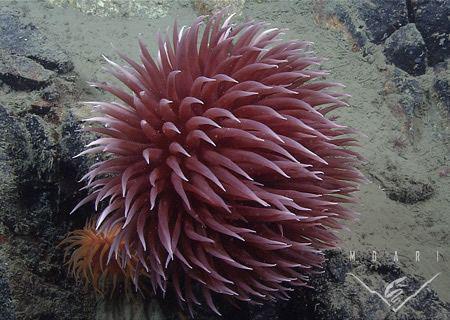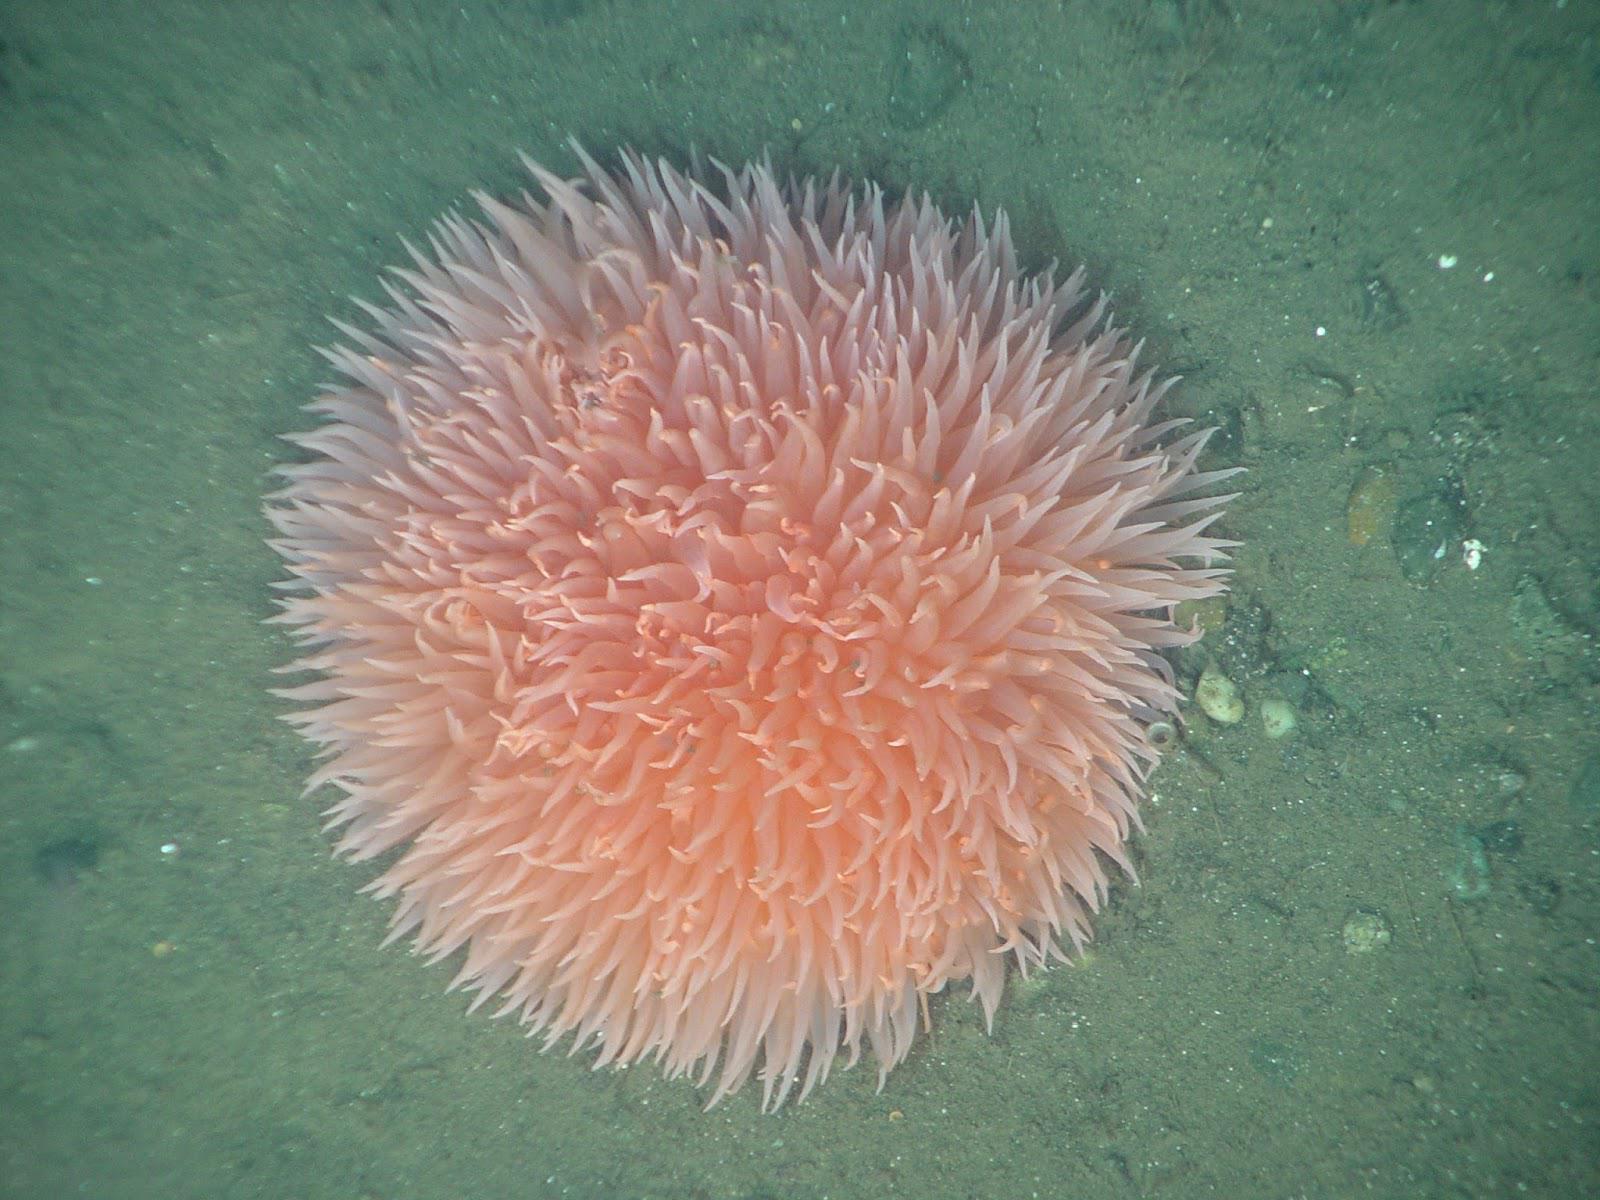The first image is the image on the left, the second image is the image on the right. Assess this claim about the two images: "Right image shows two flower-shaped anemones.". Correct or not? Answer yes or no. No. The first image is the image on the left, the second image is the image on the right. For the images displayed, is the sentence "There are two anemones in the image on the right." factually correct? Answer yes or no. No. 